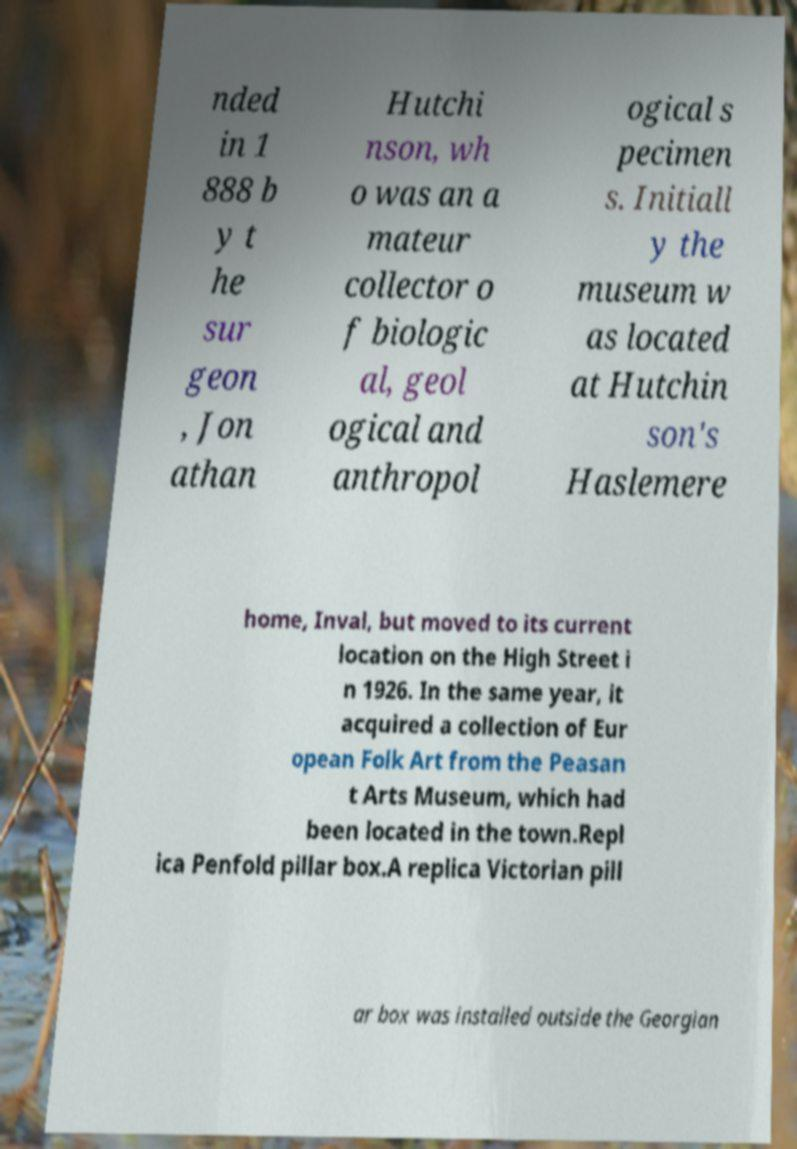I need the written content from this picture converted into text. Can you do that? nded in 1 888 b y t he sur geon , Jon athan Hutchi nson, wh o was an a mateur collector o f biologic al, geol ogical and anthropol ogical s pecimen s. Initiall y the museum w as located at Hutchin son's Haslemere home, Inval, but moved to its current location on the High Street i n 1926. In the same year, it acquired a collection of Eur opean Folk Art from the Peasan t Arts Museum, which had been located in the town.Repl ica Penfold pillar box.A replica Victorian pill ar box was installed outside the Georgian 